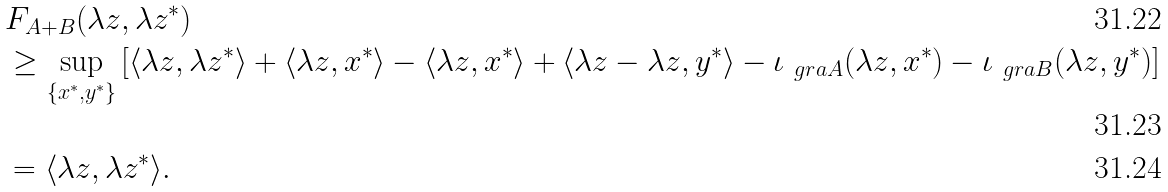<formula> <loc_0><loc_0><loc_500><loc_500>& F _ { A + B } ( \lambda z , \lambda z ^ { * } ) \\ & \geq \sup _ { \{ x ^ { * } , y ^ { * } \} } \left [ \langle \lambda z , \lambda z ^ { * } \rangle + \langle \lambda z , x ^ { * } \rangle - \langle \lambda z , x ^ { * } \rangle + \langle \lambda z - \lambda z , y ^ { * } \rangle - \iota _ { \ g r a A } ( \lambda z , x ^ { * } ) - \iota _ { \ g r a B } ( \lambda z , y ^ { * } ) \right ] \\ & = \langle \lambda z , \lambda z ^ { * } \rangle .</formula> 